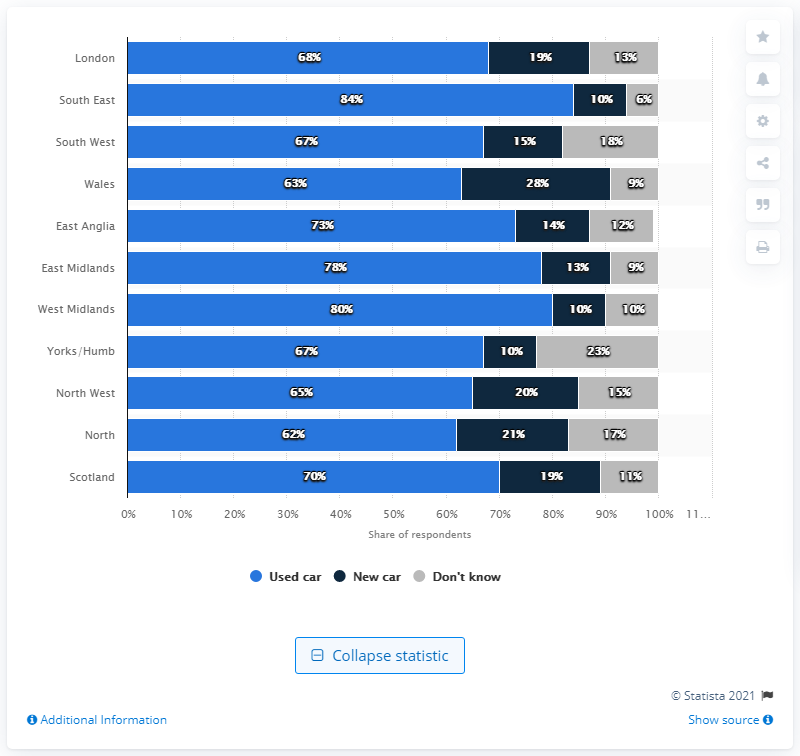Draw attention to some important aspects in this diagram. According to the survey, the region with the lowest percentage of respondents favoring used cars was Wales. 